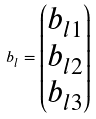Convert formula to latex. <formula><loc_0><loc_0><loc_500><loc_500>b _ { l } = \begin{pmatrix} b _ { l 1 } \\ b _ { l 2 } \\ b _ { l 3 } \end{pmatrix}</formula> 